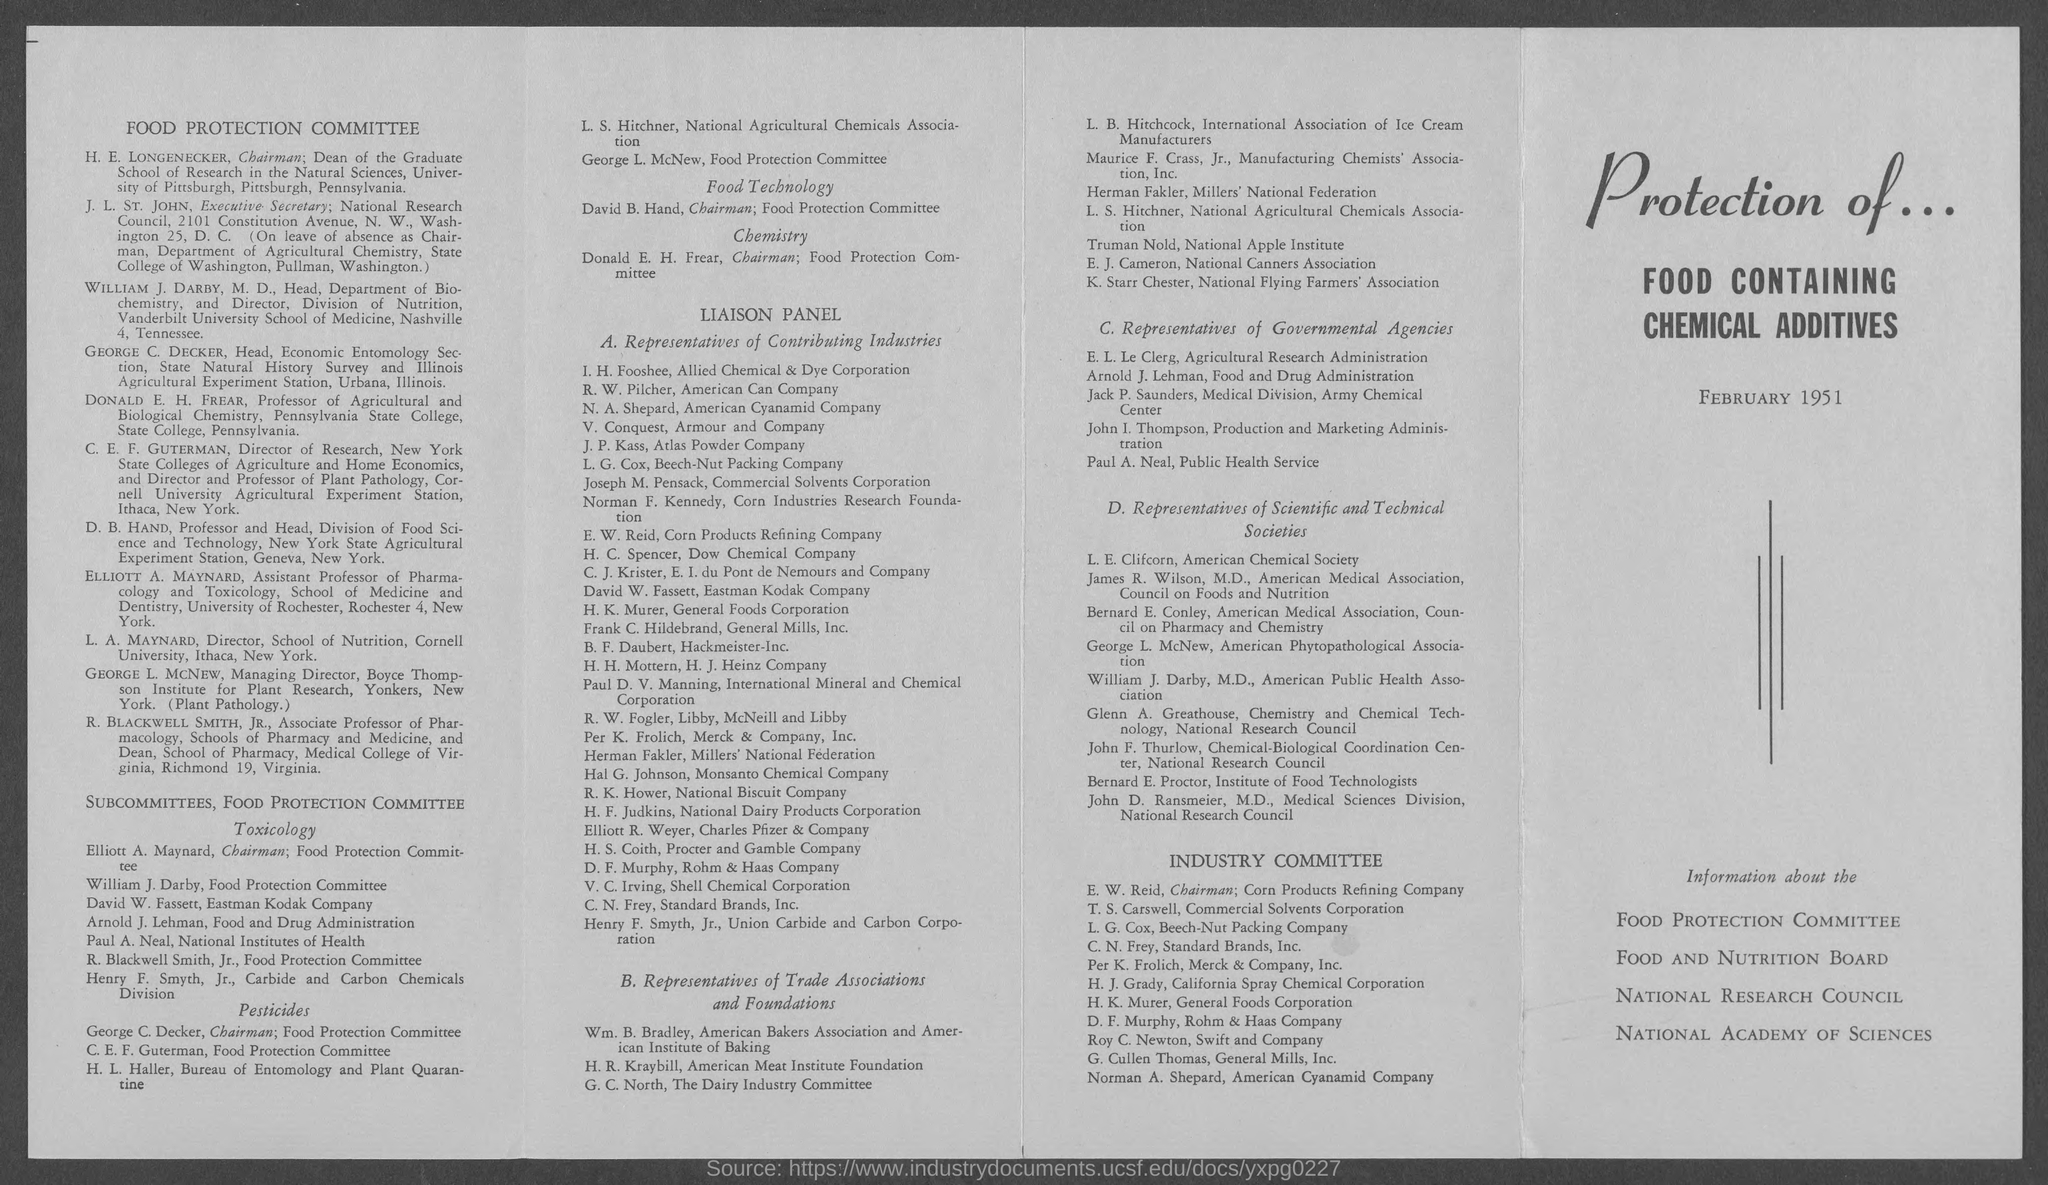What is the position of david b. hand?
Your answer should be compact. Chairman. 